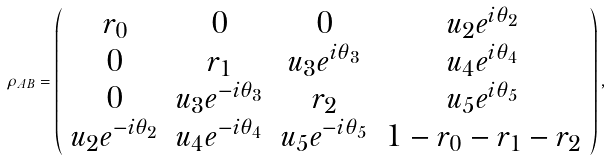<formula> <loc_0><loc_0><loc_500><loc_500>\rho _ { A B } = \left ( \begin{array} { c c c c } r _ { 0 } & 0 & 0 & u _ { 2 } e ^ { i \theta _ { 2 } } \\ 0 & r _ { 1 } & u _ { 3 } e ^ { i \theta _ { 3 } } & u _ { 4 } e ^ { i \theta _ { 4 } } \\ 0 & u _ { 3 } e ^ { - i \theta _ { 3 } } & r _ { 2 } & u _ { 5 } e ^ { i \theta _ { 5 } } \\ u _ { 2 } e ^ { - i \theta _ { 2 } } & u _ { 4 } e ^ { - i \theta _ { 4 } } & u _ { 5 } e ^ { - i \theta _ { 5 } } & 1 - r _ { 0 } - r _ { 1 } - r _ { 2 } \end{array} \right ) ,</formula> 